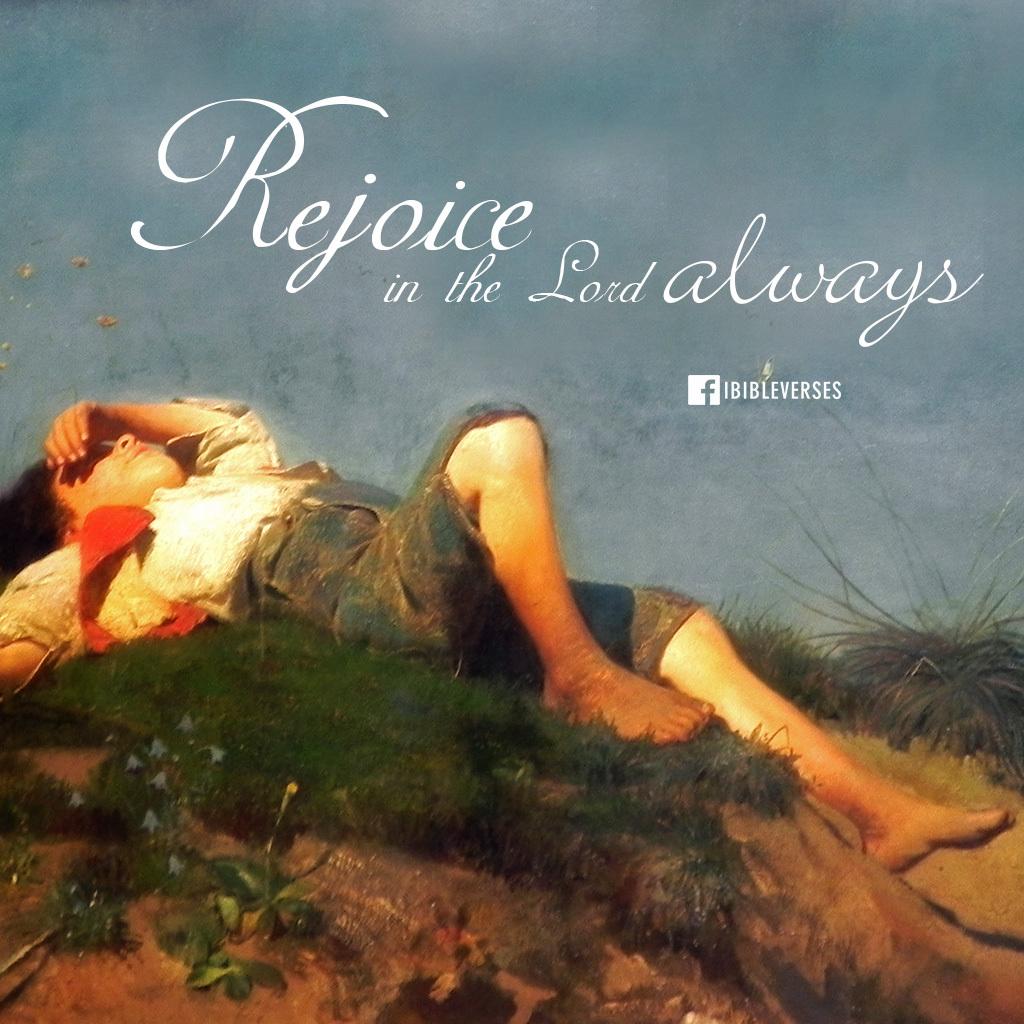Where was this poster published?
Make the answer very short. Unanswerable. In what does the poster say we should always rejoice?
Provide a succinct answer. In the lord. 